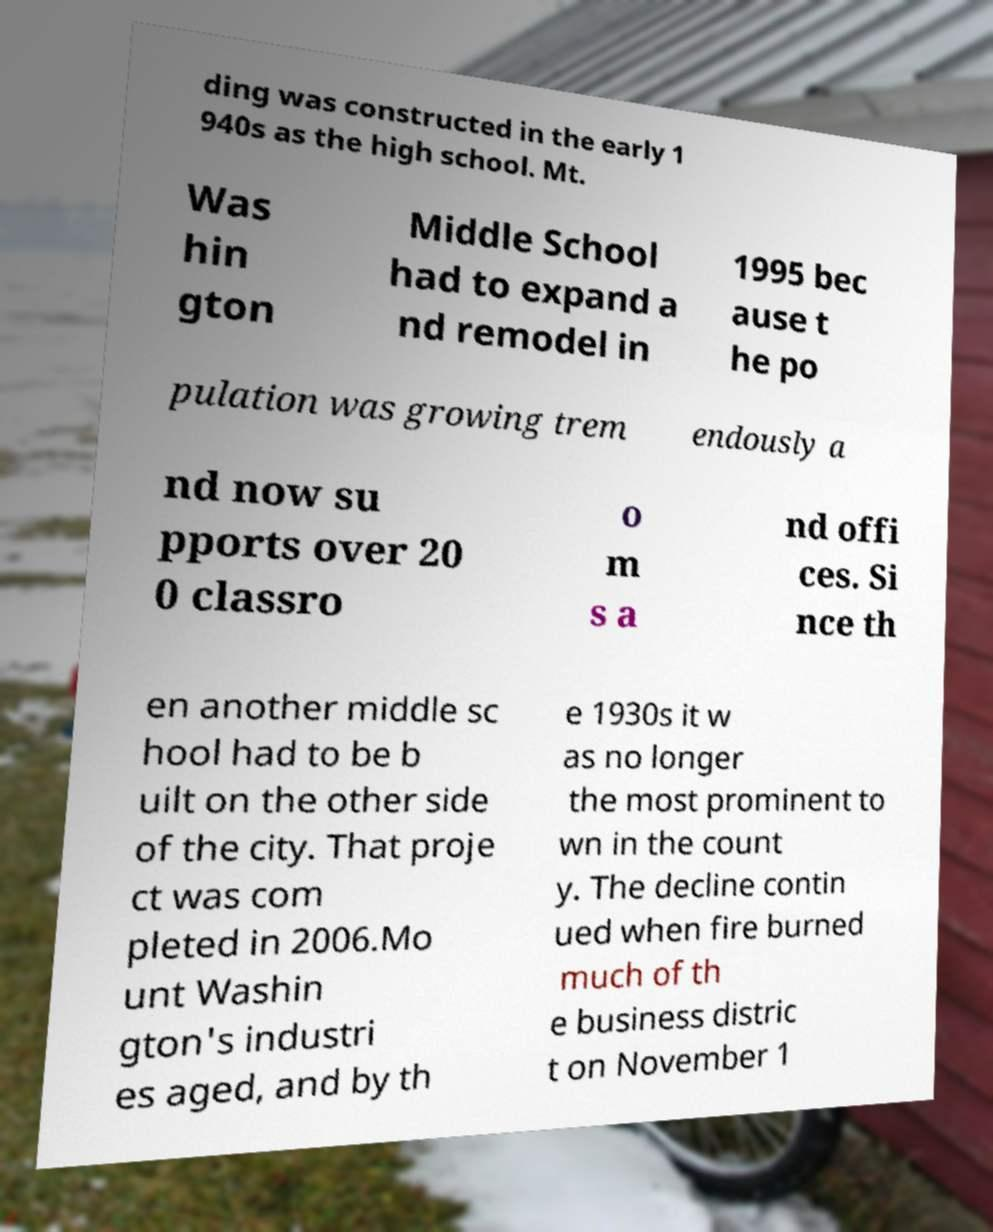I need the written content from this picture converted into text. Can you do that? ding was constructed in the early 1 940s as the high school. Mt. Was hin gton Middle School had to expand a nd remodel in 1995 bec ause t he po pulation was growing trem endously a nd now su pports over 20 0 classro o m s a nd offi ces. Si nce th en another middle sc hool had to be b uilt on the other side of the city. That proje ct was com pleted in 2006.Mo unt Washin gton's industri es aged, and by th e 1930s it w as no longer the most prominent to wn in the count y. The decline contin ued when fire burned much of th e business distric t on November 1 